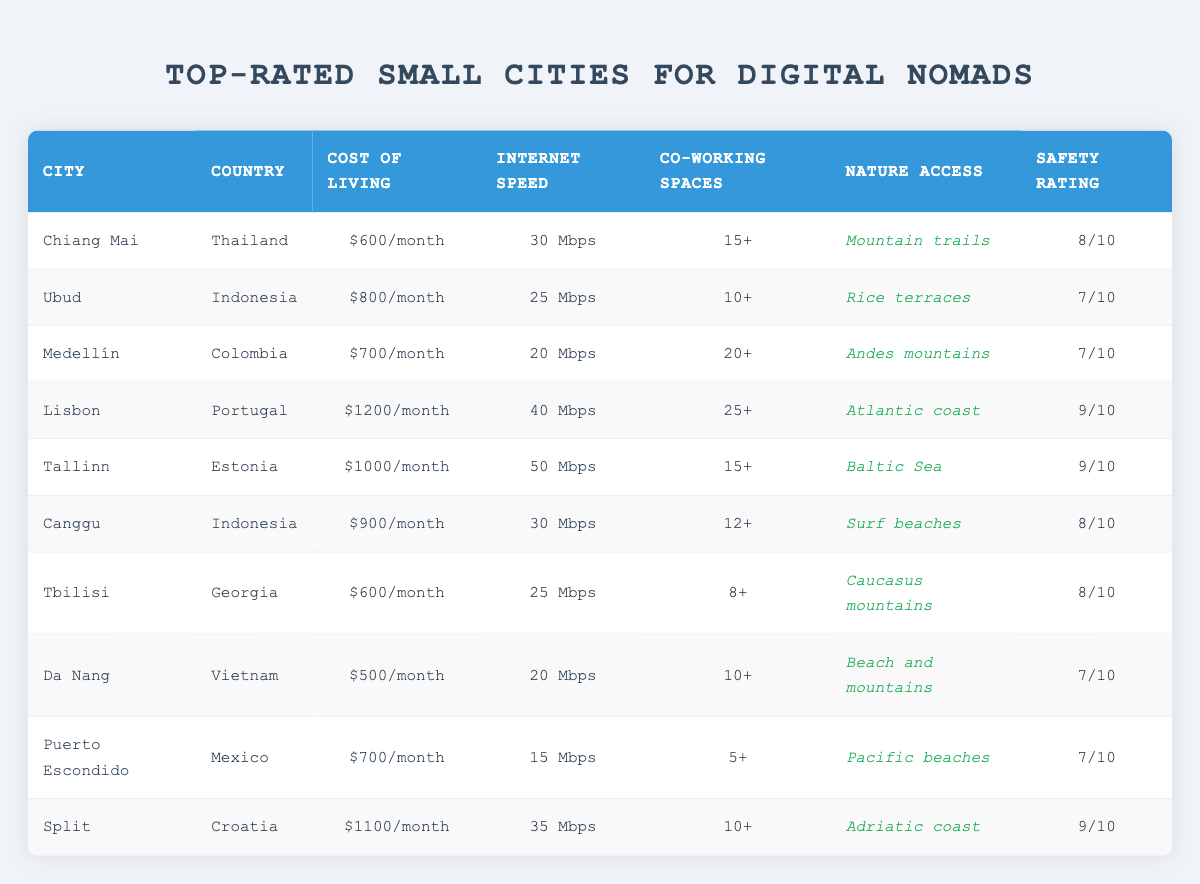What is the safety rating of Tbilisi? Tbilisi has a safety rating listed in the table as 8/10. I found this by locating the row for Tbilisi and reading the corresponding column for safety rating.
Answer: 8/10 How many co-working spaces are available in Lisbon? The table shows that Lisbon has 25+ co-working spaces. This is found by looking at the row for Lisbon and checking the co-working spaces column.
Answer: 25+ Which city has the highest internet speed? The city with the highest internet speed is Tallinn, which has 50 Mbps. This was determined by scanning the internet speed column and identifying the maximum value.
Answer: 50 Mbps What is the average cost of living for the cities listed? To calculate the average, first convert the costs into numerical values: 600, 800, 700, 1200, 1000, 900, 600, 500, 700, and 1100. Summing these gives 6100, and dividing by 10 (the number of cities) results in an average of 610.
Answer: $610/month Is the nature access in Da Nang more appealing than that in Puerto Escondido? Da Nang offers access to "Beach and mountains," while Puerto Escondido offers "Pacific beaches." This is subjective but suggests that both have attractive nature access. Thus, it can be argued that they are equally appealing depending on one's preferences.
Answer: Yes, depending on personal preference Which of these cities has the lowest cost of living and how does it compare to the highest? Da Nang has the lowest cost of living at $500/month, while Lisbon has the highest at $1200/month. The difference between them is $1200 - $500 = $700.
Answer: $500/month; $700 difference Which city has a lower safety rating: Ubud or Medellín? Ubud has a safety rating of 7/10, while Medellín also has a safety rating of 7/10. Comparing these two ratings shows that they are equal.
Answer: Neither; both have 7/10 If you had a budget of $800/month, which cities would you be able to live in? Only the cities with a cost of living of $800 or less would be suitable. By reviewing the cost of living column, I find that Chiang Mai ($600/month), Tbilisi ($600/month), and Da Nang ($500/month) meet this criterion.
Answer: Chiang Mai, Tbilisi, Da Nang Which city offers both high internet speed and a lower cost of living? I checked the cost of living against the internet speed in the table. Chiang Mai, with a cost of $600/month and internet speed of 30 Mbps, fits the criteria best.
Answer: Chiang Mai 